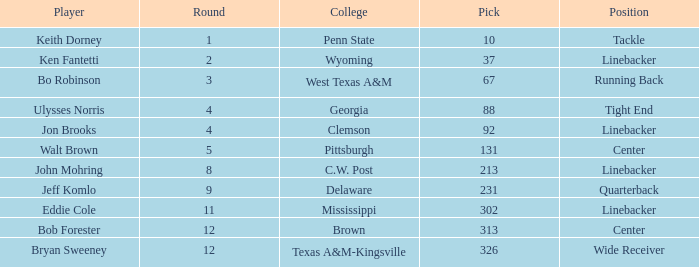What is the college pick for 213? C.W. Post. 